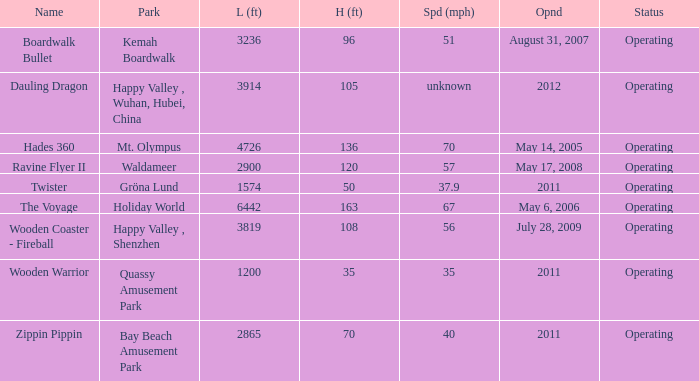What park is Boardwalk Bullet located in? Kemah Boardwalk. Could you parse the entire table? {'header': ['Name', 'Park', 'L (ft)', 'H (ft)', 'Spd (mph)', 'Opnd', 'Status'], 'rows': [['Boardwalk Bullet', 'Kemah Boardwalk', '3236', '96', '51', 'August 31, 2007', 'Operating'], ['Dauling Dragon', 'Happy Valley , Wuhan, Hubei, China', '3914', '105', 'unknown', '2012', 'Operating'], ['Hades 360', 'Mt. Olympus', '4726', '136', '70', 'May 14, 2005', 'Operating'], ['Ravine Flyer II', 'Waldameer', '2900', '120', '57', 'May 17, 2008', 'Operating'], ['Twister', 'Gröna Lund', '1574', '50', '37.9', '2011', 'Operating'], ['The Voyage', 'Holiday World', '6442', '163', '67', 'May 6, 2006', 'Operating'], ['Wooden Coaster - Fireball', 'Happy Valley , Shenzhen', '3819', '108', '56', 'July 28, 2009', 'Operating'], ['Wooden Warrior', 'Quassy Amusement Park', '1200', '35', '35', '2011', 'Operating'], ['Zippin Pippin', 'Bay Beach Amusement Park', '2865', '70', '40', '2011', 'Operating']]} 